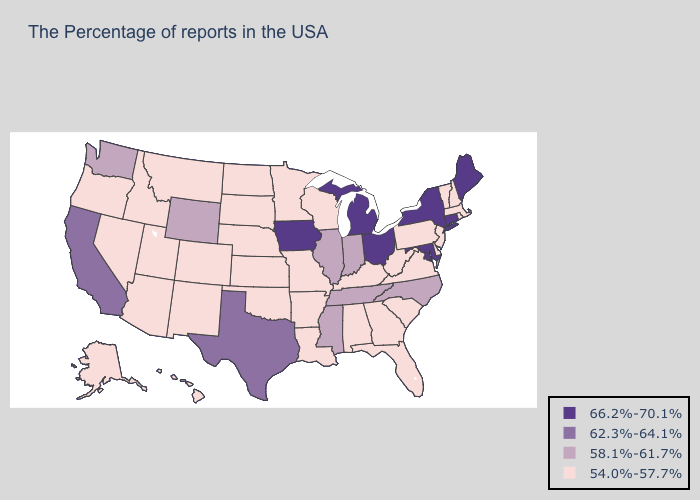Name the states that have a value in the range 54.0%-57.7%?
Short answer required. Massachusetts, Rhode Island, New Hampshire, Vermont, New Jersey, Delaware, Pennsylvania, Virginia, South Carolina, West Virginia, Florida, Georgia, Kentucky, Alabama, Wisconsin, Louisiana, Missouri, Arkansas, Minnesota, Kansas, Nebraska, Oklahoma, South Dakota, North Dakota, Colorado, New Mexico, Utah, Montana, Arizona, Idaho, Nevada, Oregon, Alaska, Hawaii. Does Maine have the same value as Vermont?
Concise answer only. No. Name the states that have a value in the range 66.2%-70.1%?
Quick response, please. Maine, Connecticut, New York, Maryland, Ohio, Michigan, Iowa. What is the highest value in states that border Idaho?
Write a very short answer. 58.1%-61.7%. What is the highest value in states that border Minnesota?
Write a very short answer. 66.2%-70.1%. Among the states that border Kansas , which have the lowest value?
Short answer required. Missouri, Nebraska, Oklahoma, Colorado. Which states have the lowest value in the Northeast?
Short answer required. Massachusetts, Rhode Island, New Hampshire, Vermont, New Jersey, Pennsylvania. Does New Jersey have a higher value than Arkansas?
Be succinct. No. Which states have the highest value in the USA?
Concise answer only. Maine, Connecticut, New York, Maryland, Ohio, Michigan, Iowa. Name the states that have a value in the range 62.3%-64.1%?
Write a very short answer. Texas, California. What is the lowest value in the USA?
Answer briefly. 54.0%-57.7%. Does the first symbol in the legend represent the smallest category?
Answer briefly. No. How many symbols are there in the legend?
Be succinct. 4. Name the states that have a value in the range 66.2%-70.1%?
Short answer required. Maine, Connecticut, New York, Maryland, Ohio, Michigan, Iowa. Does the map have missing data?
Answer briefly. No. 